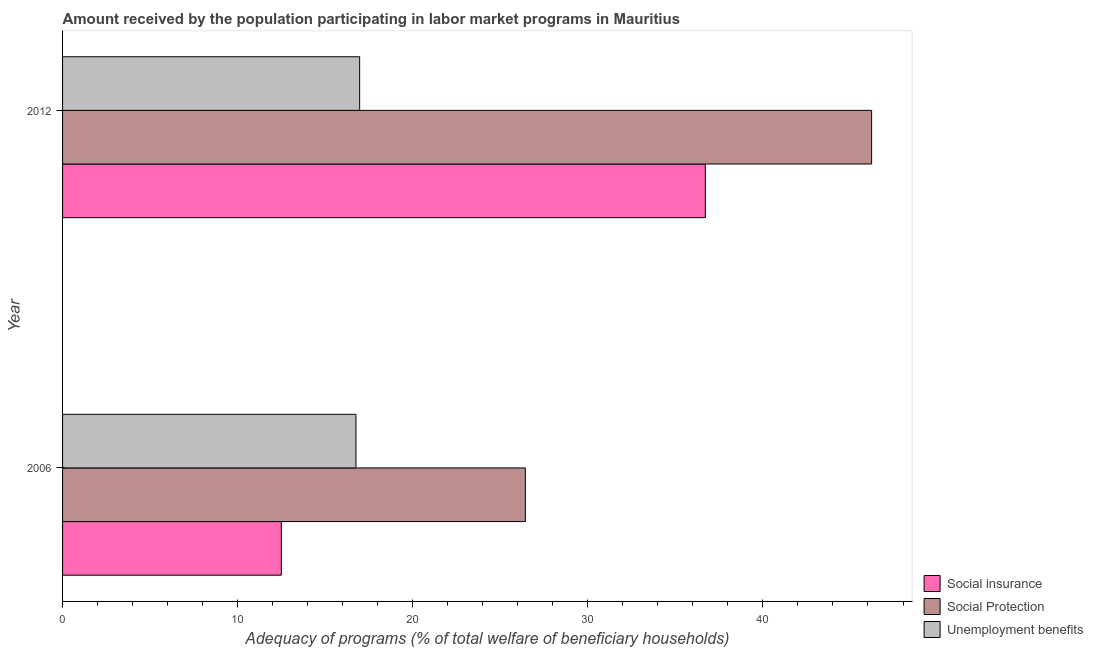How many bars are there on the 2nd tick from the top?
Offer a terse response. 3. How many bars are there on the 1st tick from the bottom?
Your answer should be very brief. 3. What is the amount received by the population participating in social insurance programs in 2006?
Provide a succinct answer. 12.49. Across all years, what is the maximum amount received by the population participating in unemployment benefits programs?
Provide a short and direct response. 16.97. Across all years, what is the minimum amount received by the population participating in social protection programs?
Offer a terse response. 26.43. What is the total amount received by the population participating in unemployment benefits programs in the graph?
Provide a succinct answer. 33.73. What is the difference between the amount received by the population participating in social insurance programs in 2006 and that in 2012?
Keep it short and to the point. -24.22. What is the difference between the amount received by the population participating in social protection programs in 2006 and the amount received by the population participating in social insurance programs in 2012?
Provide a succinct answer. -10.28. What is the average amount received by the population participating in social insurance programs per year?
Keep it short and to the point. 24.6. In the year 2006, what is the difference between the amount received by the population participating in social insurance programs and amount received by the population participating in unemployment benefits programs?
Provide a succinct answer. -4.26. In how many years, is the amount received by the population participating in social insurance programs greater than 12 %?
Offer a very short reply. 2. What is the ratio of the amount received by the population participating in social protection programs in 2006 to that in 2012?
Your response must be concise. 0.57. Is the amount received by the population participating in unemployment benefits programs in 2006 less than that in 2012?
Provide a short and direct response. Yes. Is the difference between the amount received by the population participating in social protection programs in 2006 and 2012 greater than the difference between the amount received by the population participating in unemployment benefits programs in 2006 and 2012?
Offer a very short reply. No. In how many years, is the amount received by the population participating in social protection programs greater than the average amount received by the population participating in social protection programs taken over all years?
Provide a short and direct response. 1. What does the 2nd bar from the top in 2012 represents?
Make the answer very short. Social Protection. What does the 2nd bar from the bottom in 2012 represents?
Give a very brief answer. Social Protection. Is it the case that in every year, the sum of the amount received by the population participating in social insurance programs and amount received by the population participating in social protection programs is greater than the amount received by the population participating in unemployment benefits programs?
Your answer should be very brief. Yes. Are all the bars in the graph horizontal?
Make the answer very short. Yes. Are the values on the major ticks of X-axis written in scientific E-notation?
Your response must be concise. No. Does the graph contain any zero values?
Offer a very short reply. No. How are the legend labels stacked?
Provide a short and direct response. Vertical. What is the title of the graph?
Keep it short and to the point. Amount received by the population participating in labor market programs in Mauritius. Does "Social insurance" appear as one of the legend labels in the graph?
Keep it short and to the point. Yes. What is the label or title of the X-axis?
Provide a succinct answer. Adequacy of programs (% of total welfare of beneficiary households). What is the label or title of the Y-axis?
Your answer should be compact. Year. What is the Adequacy of programs (% of total welfare of beneficiary households) in Social insurance in 2006?
Offer a very short reply. 12.49. What is the Adequacy of programs (% of total welfare of beneficiary households) of Social Protection in 2006?
Give a very brief answer. 26.43. What is the Adequacy of programs (% of total welfare of beneficiary households) of Unemployment benefits in 2006?
Ensure brevity in your answer.  16.76. What is the Adequacy of programs (% of total welfare of beneficiary households) of Social insurance in 2012?
Ensure brevity in your answer.  36.71. What is the Adequacy of programs (% of total welfare of beneficiary households) of Social Protection in 2012?
Make the answer very short. 46.21. What is the Adequacy of programs (% of total welfare of beneficiary households) in Unemployment benefits in 2012?
Your answer should be compact. 16.97. Across all years, what is the maximum Adequacy of programs (% of total welfare of beneficiary households) of Social insurance?
Your response must be concise. 36.71. Across all years, what is the maximum Adequacy of programs (% of total welfare of beneficiary households) of Social Protection?
Your answer should be compact. 46.21. Across all years, what is the maximum Adequacy of programs (% of total welfare of beneficiary households) in Unemployment benefits?
Provide a succinct answer. 16.97. Across all years, what is the minimum Adequacy of programs (% of total welfare of beneficiary households) of Social insurance?
Provide a short and direct response. 12.49. Across all years, what is the minimum Adequacy of programs (% of total welfare of beneficiary households) of Social Protection?
Give a very brief answer. 26.43. Across all years, what is the minimum Adequacy of programs (% of total welfare of beneficiary households) in Unemployment benefits?
Provide a succinct answer. 16.76. What is the total Adequacy of programs (% of total welfare of beneficiary households) in Social insurance in the graph?
Offer a very short reply. 49.2. What is the total Adequacy of programs (% of total welfare of beneficiary households) of Social Protection in the graph?
Offer a very short reply. 72.64. What is the total Adequacy of programs (% of total welfare of beneficiary households) of Unemployment benefits in the graph?
Offer a terse response. 33.73. What is the difference between the Adequacy of programs (% of total welfare of beneficiary households) in Social insurance in 2006 and that in 2012?
Ensure brevity in your answer.  -24.22. What is the difference between the Adequacy of programs (% of total welfare of beneficiary households) in Social Protection in 2006 and that in 2012?
Your answer should be very brief. -19.78. What is the difference between the Adequacy of programs (% of total welfare of beneficiary households) in Unemployment benefits in 2006 and that in 2012?
Your answer should be very brief. -0.21. What is the difference between the Adequacy of programs (% of total welfare of beneficiary households) in Social insurance in 2006 and the Adequacy of programs (% of total welfare of beneficiary households) in Social Protection in 2012?
Offer a very short reply. -33.71. What is the difference between the Adequacy of programs (% of total welfare of beneficiary households) in Social insurance in 2006 and the Adequacy of programs (% of total welfare of beneficiary households) in Unemployment benefits in 2012?
Provide a succinct answer. -4.47. What is the difference between the Adequacy of programs (% of total welfare of beneficiary households) in Social Protection in 2006 and the Adequacy of programs (% of total welfare of beneficiary households) in Unemployment benefits in 2012?
Provide a short and direct response. 9.46. What is the average Adequacy of programs (% of total welfare of beneficiary households) in Social insurance per year?
Provide a succinct answer. 24.6. What is the average Adequacy of programs (% of total welfare of beneficiary households) in Social Protection per year?
Give a very brief answer. 36.32. What is the average Adequacy of programs (% of total welfare of beneficiary households) in Unemployment benefits per year?
Provide a short and direct response. 16.86. In the year 2006, what is the difference between the Adequacy of programs (% of total welfare of beneficiary households) in Social insurance and Adequacy of programs (% of total welfare of beneficiary households) in Social Protection?
Your answer should be very brief. -13.94. In the year 2006, what is the difference between the Adequacy of programs (% of total welfare of beneficiary households) in Social insurance and Adequacy of programs (% of total welfare of beneficiary households) in Unemployment benefits?
Give a very brief answer. -4.26. In the year 2006, what is the difference between the Adequacy of programs (% of total welfare of beneficiary households) of Social Protection and Adequacy of programs (% of total welfare of beneficiary households) of Unemployment benefits?
Ensure brevity in your answer.  9.67. In the year 2012, what is the difference between the Adequacy of programs (% of total welfare of beneficiary households) in Social insurance and Adequacy of programs (% of total welfare of beneficiary households) in Social Protection?
Provide a short and direct response. -9.5. In the year 2012, what is the difference between the Adequacy of programs (% of total welfare of beneficiary households) of Social insurance and Adequacy of programs (% of total welfare of beneficiary households) of Unemployment benefits?
Your answer should be very brief. 19.74. In the year 2012, what is the difference between the Adequacy of programs (% of total welfare of beneficiary households) in Social Protection and Adequacy of programs (% of total welfare of beneficiary households) in Unemployment benefits?
Provide a succinct answer. 29.24. What is the ratio of the Adequacy of programs (% of total welfare of beneficiary households) in Social insurance in 2006 to that in 2012?
Your response must be concise. 0.34. What is the ratio of the Adequacy of programs (% of total welfare of beneficiary households) in Social Protection in 2006 to that in 2012?
Provide a succinct answer. 0.57. What is the ratio of the Adequacy of programs (% of total welfare of beneficiary households) of Unemployment benefits in 2006 to that in 2012?
Make the answer very short. 0.99. What is the difference between the highest and the second highest Adequacy of programs (% of total welfare of beneficiary households) of Social insurance?
Provide a succinct answer. 24.22. What is the difference between the highest and the second highest Adequacy of programs (% of total welfare of beneficiary households) of Social Protection?
Your answer should be compact. 19.78. What is the difference between the highest and the second highest Adequacy of programs (% of total welfare of beneficiary households) of Unemployment benefits?
Your answer should be very brief. 0.21. What is the difference between the highest and the lowest Adequacy of programs (% of total welfare of beneficiary households) in Social insurance?
Your answer should be compact. 24.22. What is the difference between the highest and the lowest Adequacy of programs (% of total welfare of beneficiary households) in Social Protection?
Offer a terse response. 19.78. What is the difference between the highest and the lowest Adequacy of programs (% of total welfare of beneficiary households) in Unemployment benefits?
Offer a terse response. 0.21. 